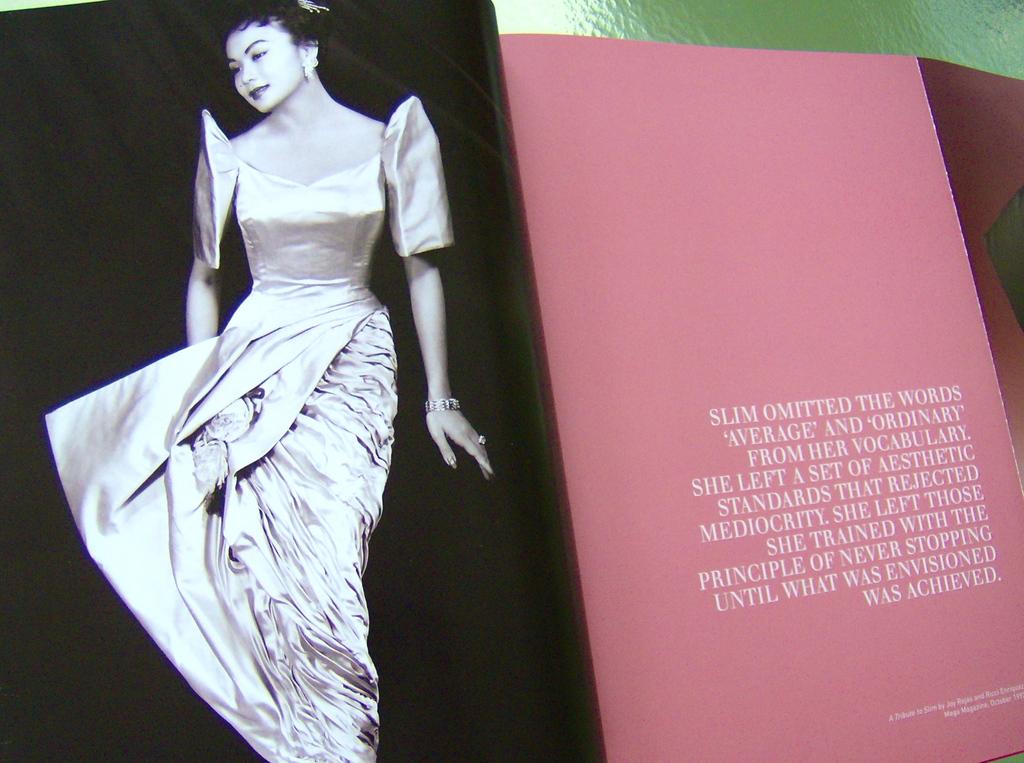What words did slim omit from her vocabulary?
Ensure brevity in your answer.  Average and ordinary. What is the last word in this whole paragraph?
Keep it short and to the point. Achieved. 